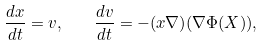Convert formula to latex. <formula><loc_0><loc_0><loc_500><loc_500>\frac { d { x } } { d t } = { v } , \quad \frac { d { v } } { d t } = - ( { x } \nabla ) ( \nabla \Phi ( { X } ) ) ,</formula> 